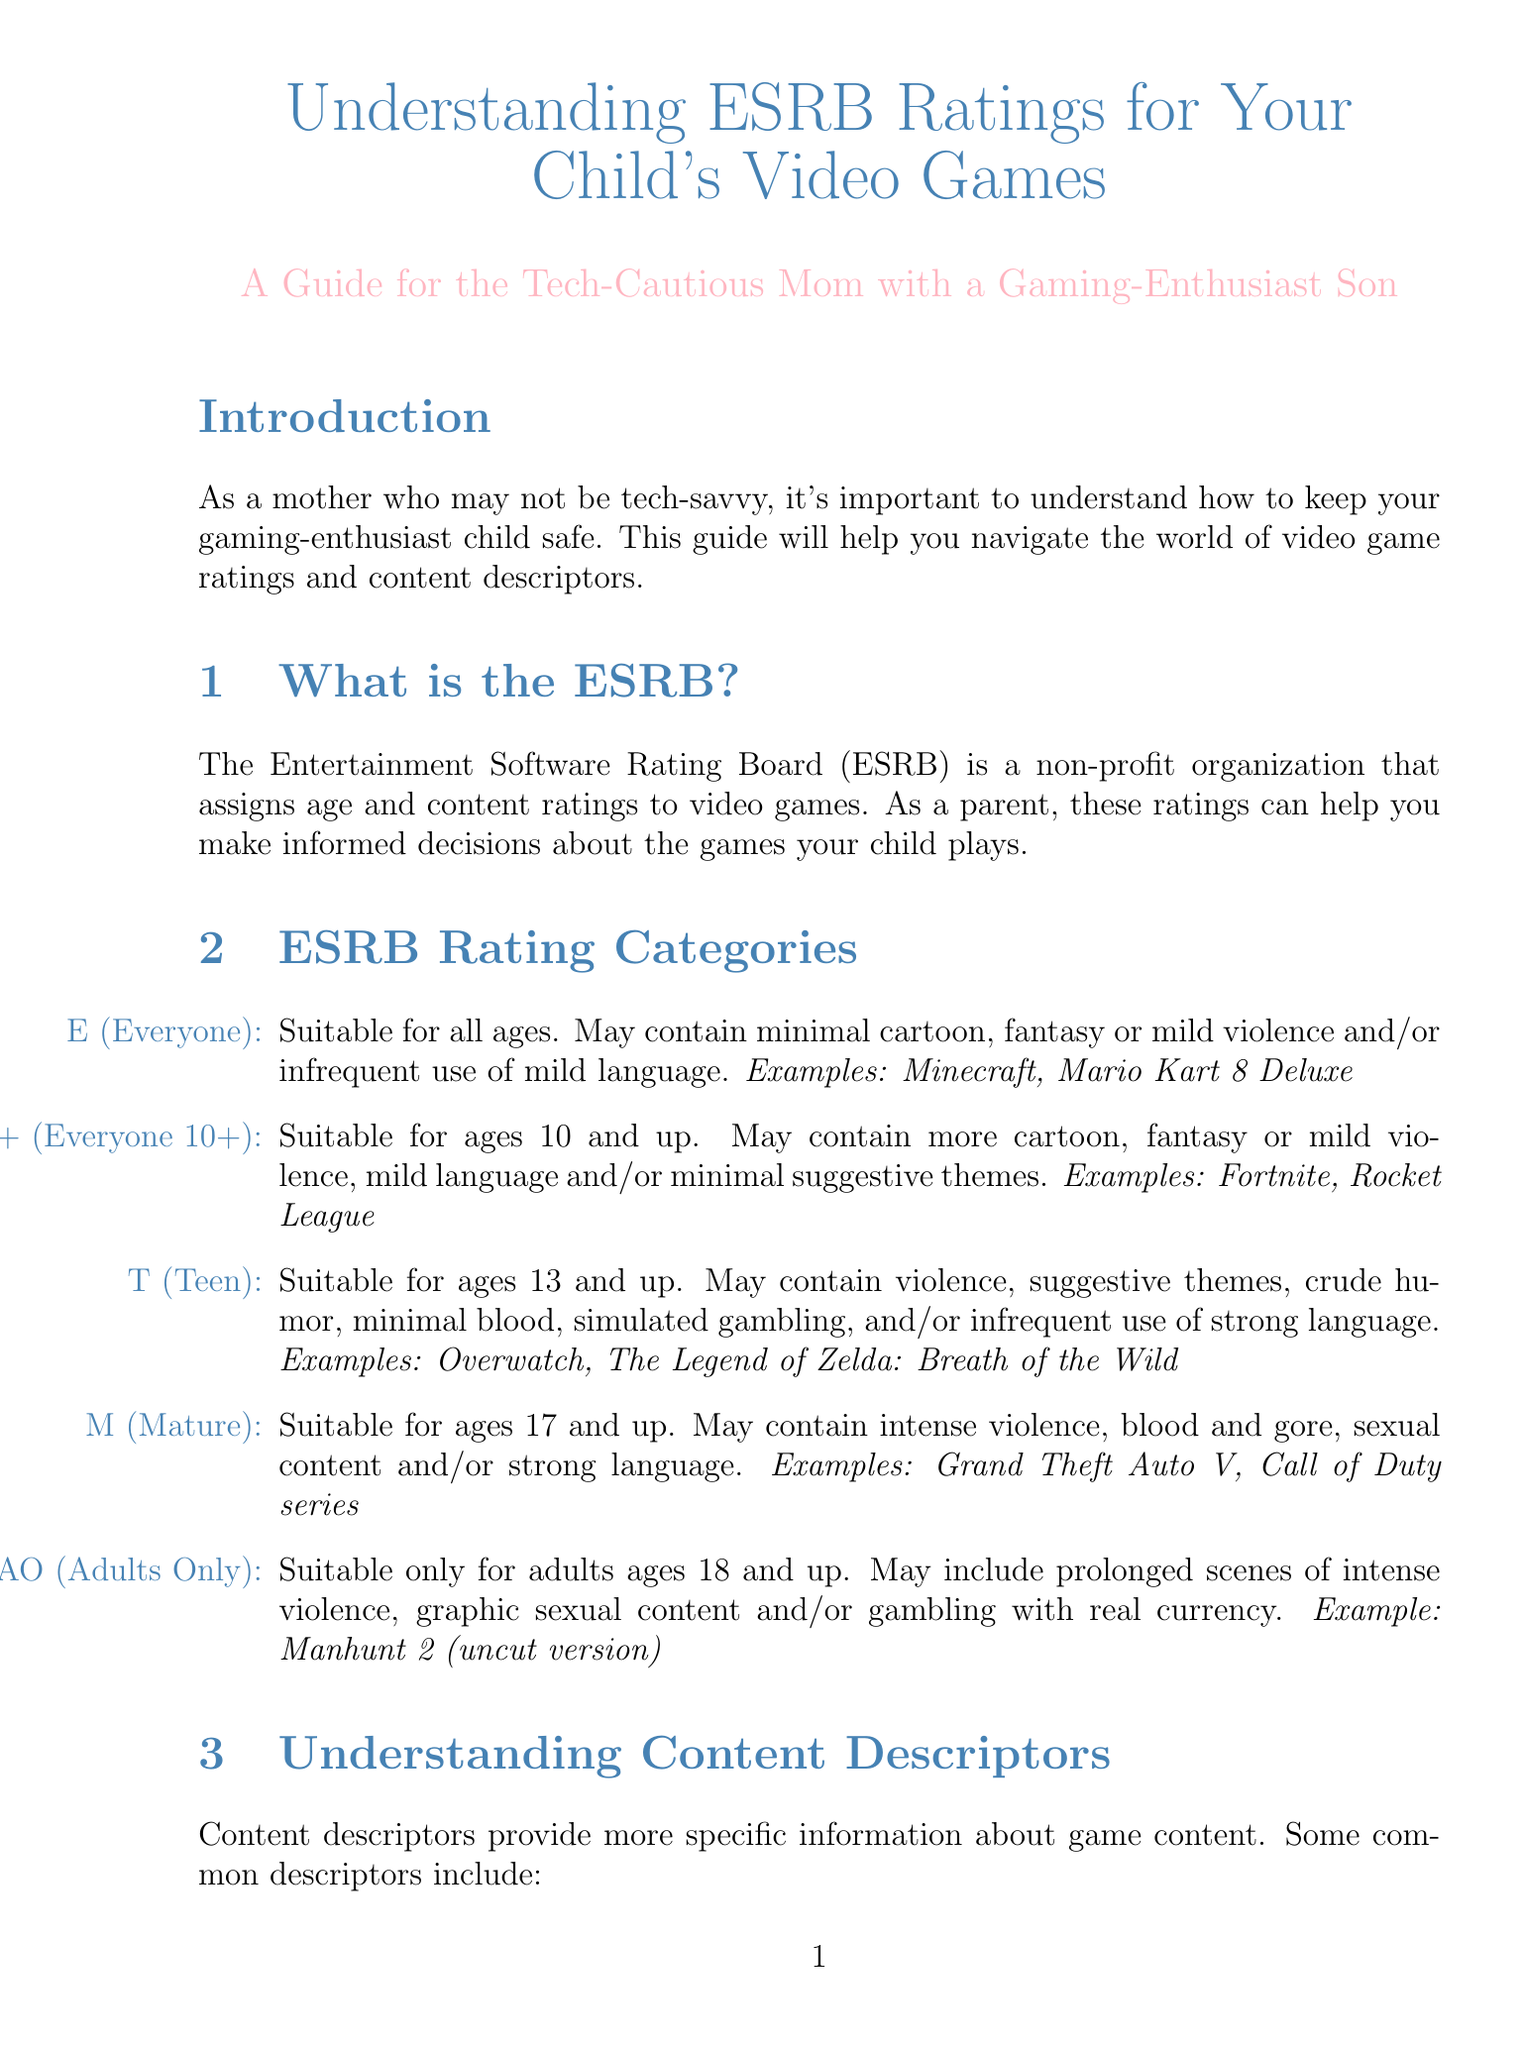What does ESRB stand for? ESRB stands for the Entertainment Software Rating Board, as mentioned in the introduction section of the document.
Answer: Entertainment Software Rating Board What age group is the E10+ rating suitable for? The document states that E10+ is suitable for ages 10 and up under the ESRB rating categories.
Answer: Ages 10 and up What content descriptor indicates playful antics? The document lists "Comic Mischief" as a content descriptor involving playful or mischievous antics.
Answer: Comic Mischief What is one of the tips for using ESRB ratings? The document includes various tips, and one is to always check the rating before purchasing a game for your child.
Answer: Always check the rating before purchasing a game What type of content can an M-rated game contain? According to the ESRB rating categories section, M-rated games may contain intense violence, blood and gore, sexual content, and/or strong language.
Answer: Intense violence, blood and gore, sexual content, strong language What is the maximum age for an AO rating? The document states that an AO rating is suitable only for adults ages 18 and up.
Answer: 18 and up Where can you find ESRB ratings for a game? The document mentions that ESRB ratings can be found on the game's packaging, in the digital store description, or on the ESRB website.
Answer: Game's packaging, digital store description, ESRB website What does the descriptor "Online Interactions Not Rated by the ESRB" warn about? The document explains this descriptor warns that player interactions in online games may expose children to unfiltered content.
Answer: Unfiltered content What is a suggested activity to balance gaming? The document advises encouraging other activities like outdoor play to promote a balanced lifestyle.
Answer: Outdoor play 